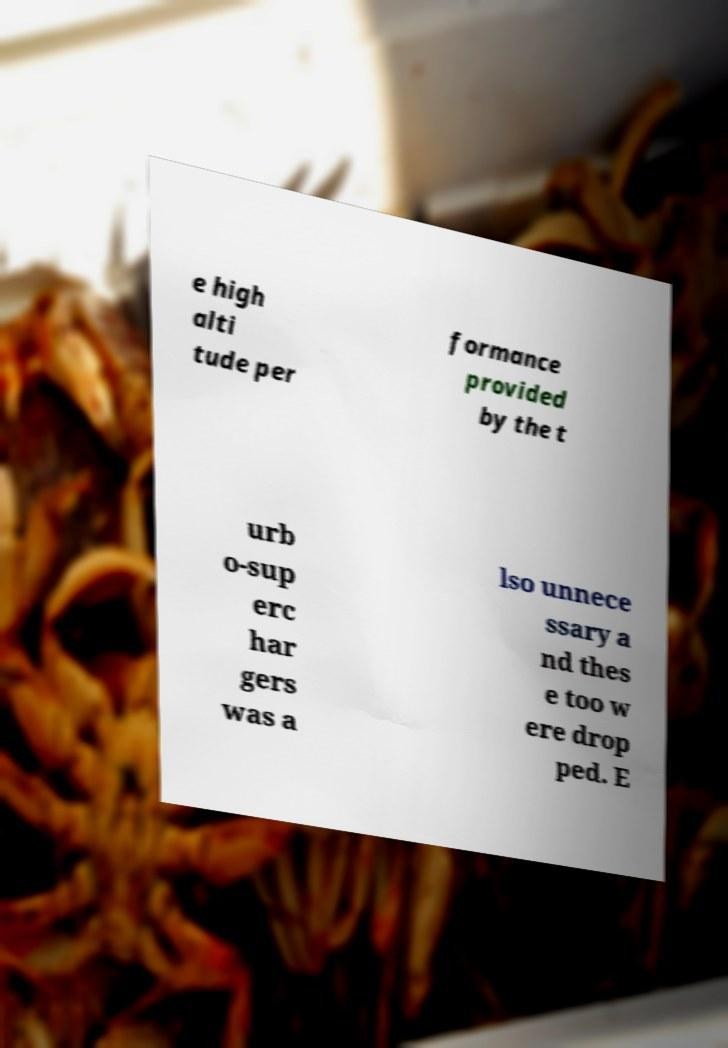For documentation purposes, I need the text within this image transcribed. Could you provide that? e high alti tude per formance provided by the t urb o-sup erc har gers was a lso unnece ssary a nd thes e too w ere drop ped. E 